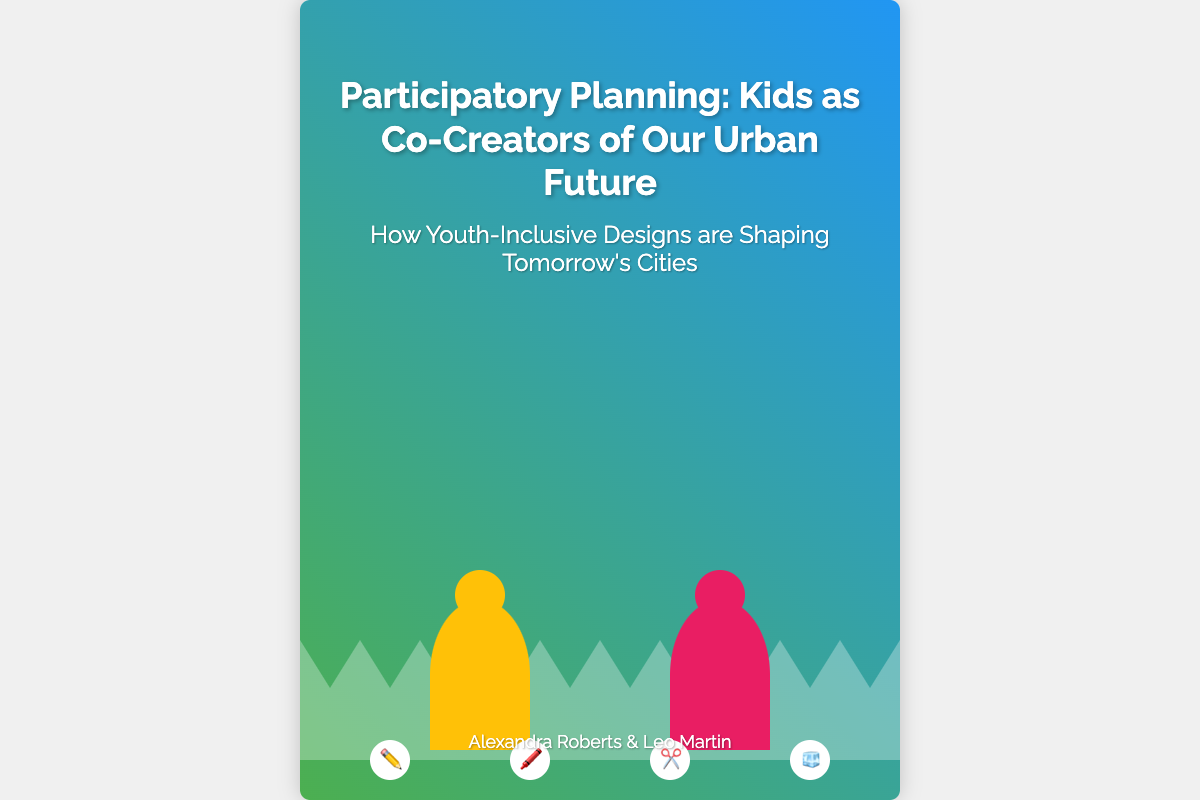What is the title of the book? The title is the main heading displayed prominently on the cover of the document.
Answer: Participatory Planning: Kids as Co-Creators of Our Urban Future Who are the authors of the book? The authors' names are typically listed at the bottom of the cover, indicating who wrote the book.
Answer: Alexandra Roberts & Leo Martin What is the subtitle of the book? The subtitle provides additional context about the book's content, usually found just below the title.
Answer: How Youth-Inclusive Designs are Shaping Tomorrow's Cities What colors are used in the background gradient? The gradient colors in the background are a key visual element of the book cover.
Answer: Green and blue How many children are depicted in the artwork? The number of child figures can indicate the representation of youth participation in urban planning.
Answer: Two What art supplies are shown on the cover? The art supplies listed signify the tools children might use in the creative planning process.
Answer: Pencil, crayon, scissors, ice cream What design concept does the cover emphasize? The overall design and depiction on the cover highlight a specific planning approach.
Answer: Collaborative design 